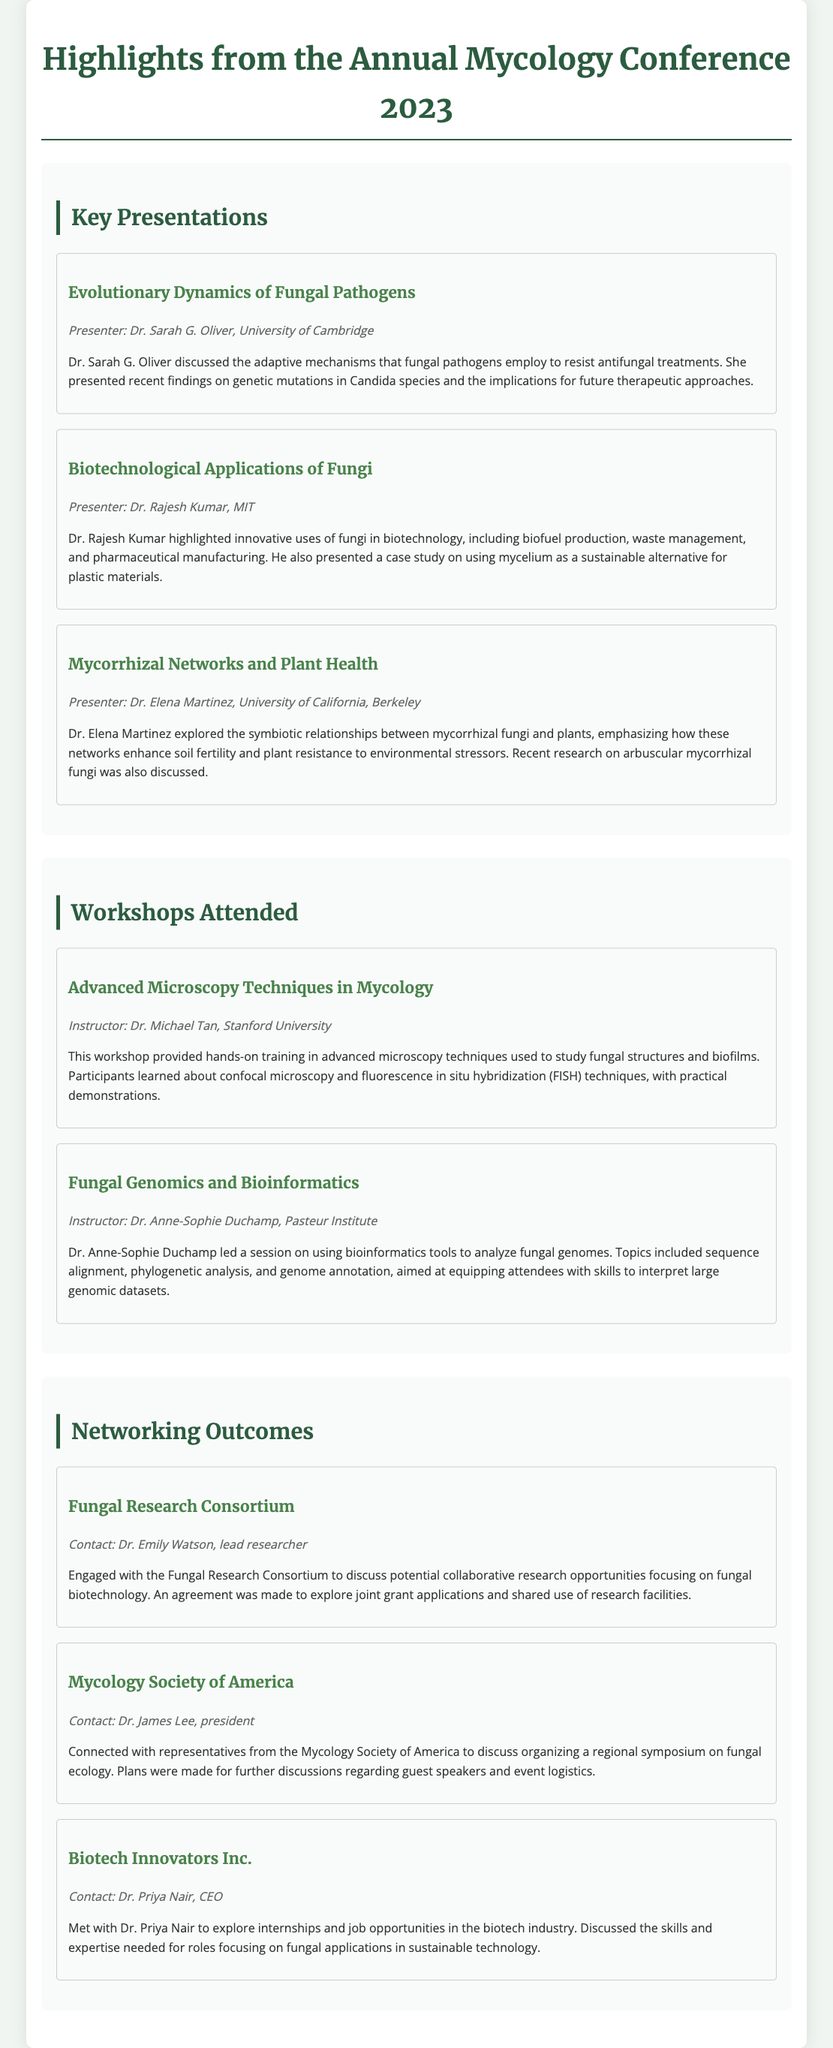What was the title of Dr. Sarah G. Oliver's presentation? The title of Dr. Sarah G. Oliver's presentation is mentioned in the document under Key Presentations, which is "Evolutionary Dynamics of Fungal Pathogens."
Answer: Evolutionary Dynamics of Fungal Pathogens Who presented on mycorrhizal networks? The information can be retrieved from the Key Presentations section where each presenter is listed along with their topic. Dr. Elena Martinez discussed mycorrhizal networks.
Answer: Dr. Elena Martinez What workshop focused on microscopy techniques? The document lists the workshops attended and includes those specific titles, where one of the workshops is "Advanced Microscopy Techniques in Mycology."
Answer: Advanced Microscopy Techniques in Mycology Who was the instructor for the Fungal Genomics and Bioinformatics workshop? The instructor's name is provided in the summary of the corresponding workshop under Workshops Attended. It states "Instructor: Dr. Anne-Sophie Duchamp."
Answer: Dr. Anne-Sophie Duchamp What organization did Dr. Emily Watson represent? This information is found in the Networking Outcomes section where it mentions engaging with the Fungal Research Consortium.
Answer: Fungal Research Consortium How many key presentations were highlighted in the document? The count of key presentations can be determined by reviewing the number of individual presentation entries listed under Key Presentations. There are three presentations listed.
Answer: Three What was discussed with Dr. Priya Nair? The Networking Outcomes section states that a meeting was held with Dr. Priya Nair to explore internships and job opportunities related to fungal applications in sustainable technology.
Answer: Internships and job opportunities What is the main focus of the collaboration discussed with the Fungal Research Consortium? This is referenced in the summary of the networking engagement, indicating that the main focus is on collaborative research opportunities in fungal biotechnology.
Answer: Collaborative research in fungal biotechnology 